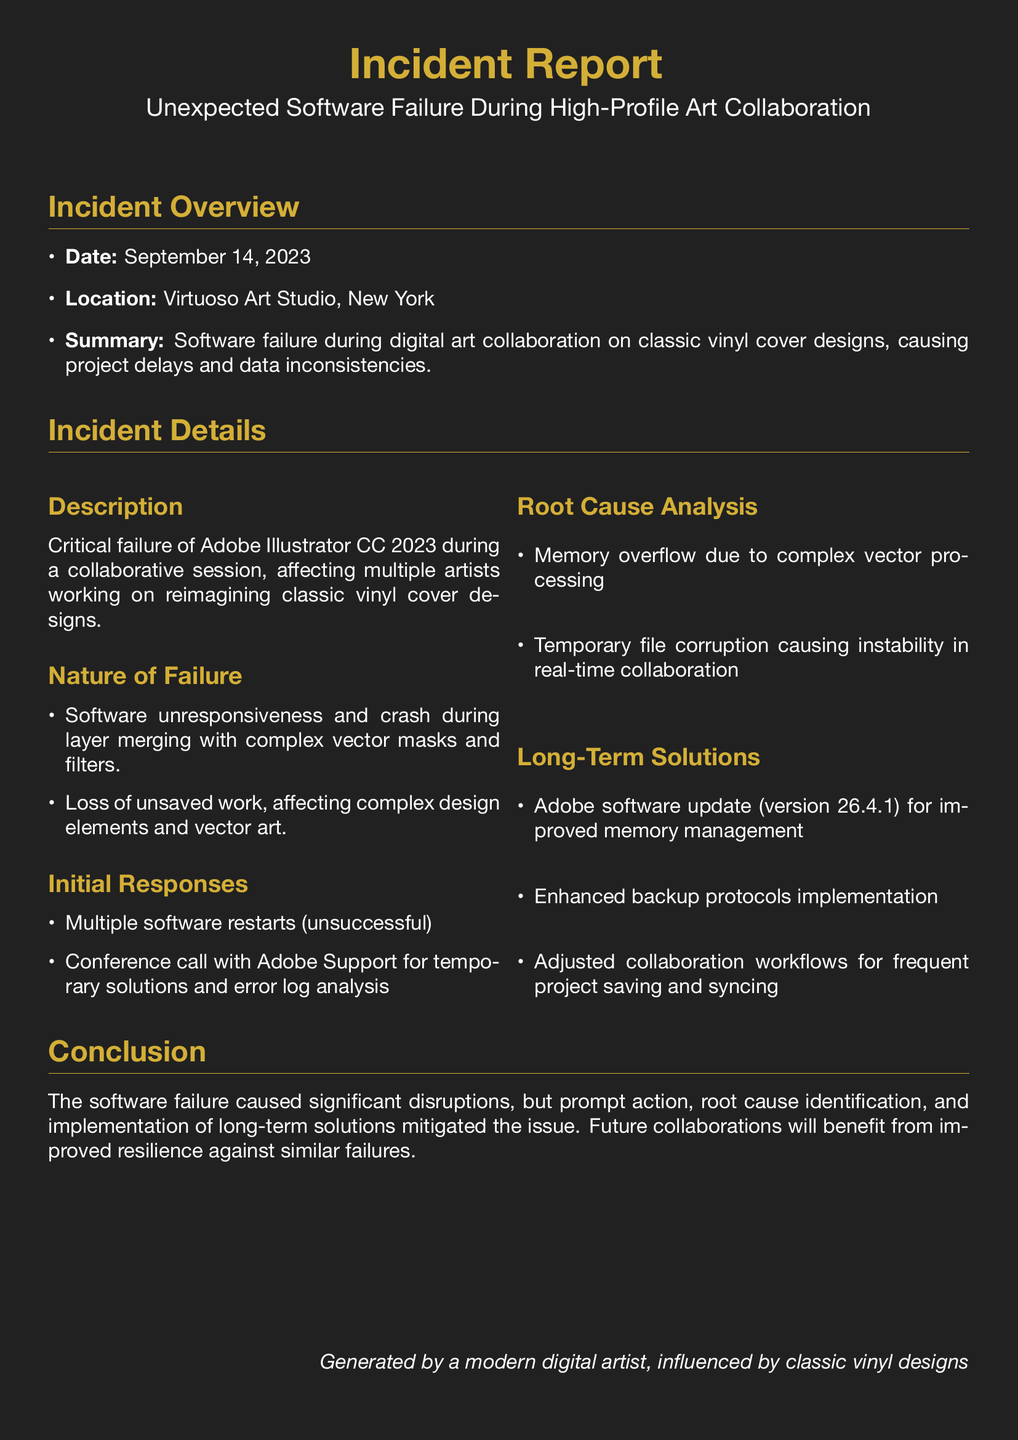What is the date of the incident? The date of the incident is found in the incident overview section.
Answer: September 14, 2023 Where did the incident occur? The location of the incident is specified in the incident overview section.
Answer: Virtuoso Art Studio, New York What software failed during the incident? The incident details mention the specific software that experienced the failure.
Answer: Adobe Illustrator CC 2023 What was identified as the root cause of the software failure? The root cause analysis section outlines the specific issue that caused the software to fail.
Answer: Memory overflow What version of the software is recommended for the long-term solution? The long-term solutions section specifies the version of Adobe software that was suggested.
Answer: 26.4.1 What was the nature of the failure? The nature of failure section describes the specifics of the software's malfunction.
Answer: Unresponsiveness and crash What action was taken initially to resolve the issue? The initial responses section identifies the first steps taken in response to the failure.
Answer: Multiple software restarts What is a recommended change for future collaborations? The long-term solutions section suggests a new approach for upcoming projects.
Answer: Adjusted collaboration workflows How many artists were affected during the incident? The description of the incident refers to the number of artists involved.
Answer: Multiple artists What type of document is this? The title of the document indicates its specific nature.
Answer: Incident Report 